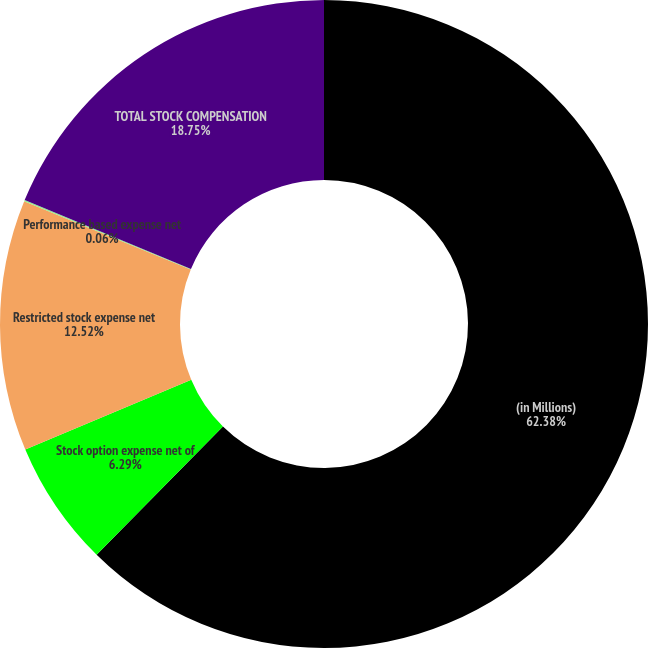Convert chart. <chart><loc_0><loc_0><loc_500><loc_500><pie_chart><fcel>(in Millions)<fcel>Stock option expense net of<fcel>Restricted stock expense net<fcel>Performance based expense net<fcel>TOTAL STOCK COMPENSATION<nl><fcel>62.38%<fcel>6.29%<fcel>12.52%<fcel>0.06%<fcel>18.75%<nl></chart> 